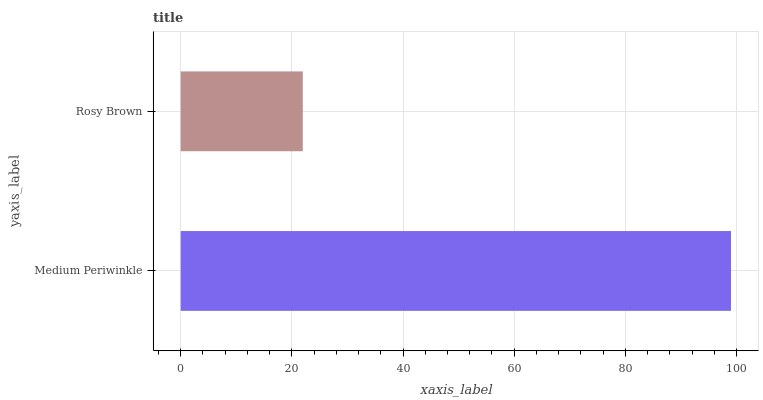Is Rosy Brown the minimum?
Answer yes or no. Yes. Is Medium Periwinkle the maximum?
Answer yes or no. Yes. Is Rosy Brown the maximum?
Answer yes or no. No. Is Medium Periwinkle greater than Rosy Brown?
Answer yes or no. Yes. Is Rosy Brown less than Medium Periwinkle?
Answer yes or no. Yes. Is Rosy Brown greater than Medium Periwinkle?
Answer yes or no. No. Is Medium Periwinkle less than Rosy Brown?
Answer yes or no. No. Is Medium Periwinkle the high median?
Answer yes or no. Yes. Is Rosy Brown the low median?
Answer yes or no. Yes. Is Rosy Brown the high median?
Answer yes or no. No. Is Medium Periwinkle the low median?
Answer yes or no. No. 